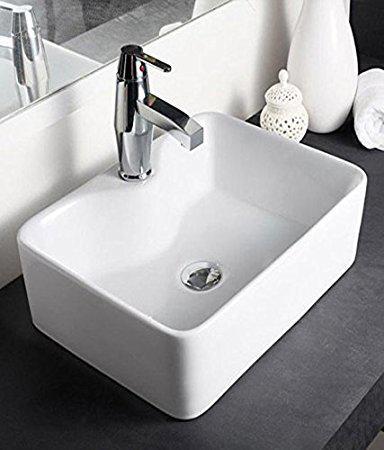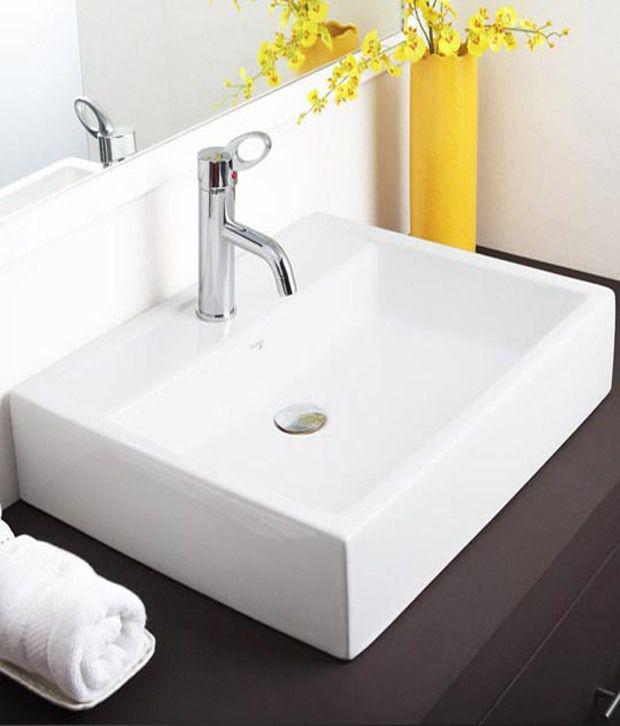The first image is the image on the left, the second image is the image on the right. Considering the images on both sides, is "At least one sink is sitting on a counter." valid? Answer yes or no. Yes. 